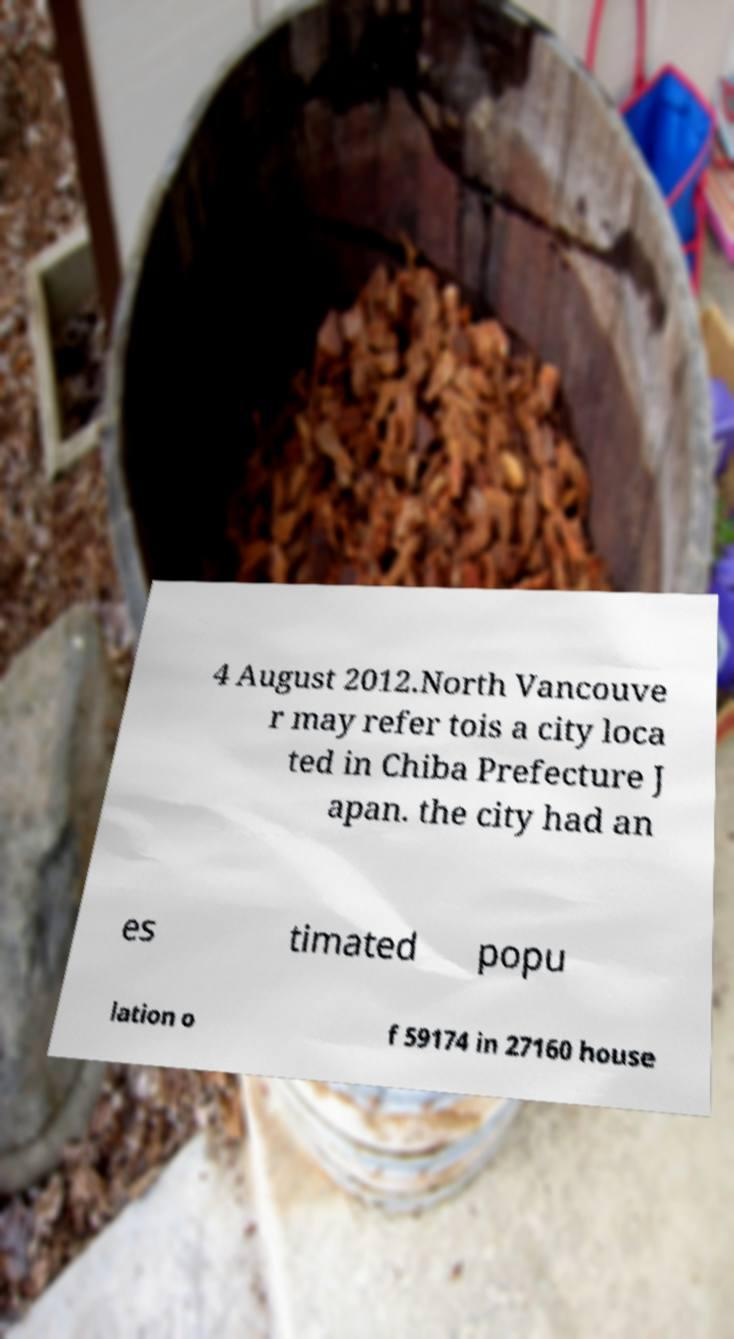Could you assist in decoding the text presented in this image and type it out clearly? 4 August 2012.North Vancouve r may refer tois a city loca ted in Chiba Prefecture J apan. the city had an es timated popu lation o f 59174 in 27160 house 